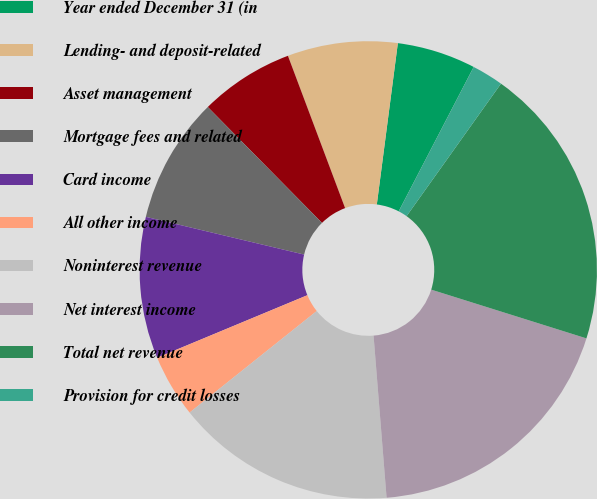<chart> <loc_0><loc_0><loc_500><loc_500><pie_chart><fcel>Year ended December 31 (in<fcel>Lending- and deposit-related<fcel>Asset management<fcel>Mortgage fees and related<fcel>Card income<fcel>All other income<fcel>Noninterest revenue<fcel>Net interest income<fcel>Total net revenue<fcel>Provision for credit losses<nl><fcel>5.56%<fcel>7.78%<fcel>6.67%<fcel>8.89%<fcel>10.0%<fcel>4.45%<fcel>15.55%<fcel>18.88%<fcel>19.99%<fcel>2.23%<nl></chart> 